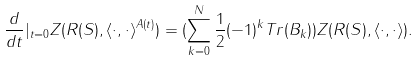<formula> <loc_0><loc_0><loc_500><loc_500>\frac { d } { d t } | _ { t = 0 } Z ( R ( S ) , \langle \cdot , \cdot \rangle ^ { A ( t ) } ) = ( \sum _ { k = 0 } ^ { N } \frac { 1 } { 2 } ( - 1 ) ^ { k } T r ( B _ { k } ) ) Z ( R ( S ) , \langle \cdot , \cdot \rangle ) .</formula> 